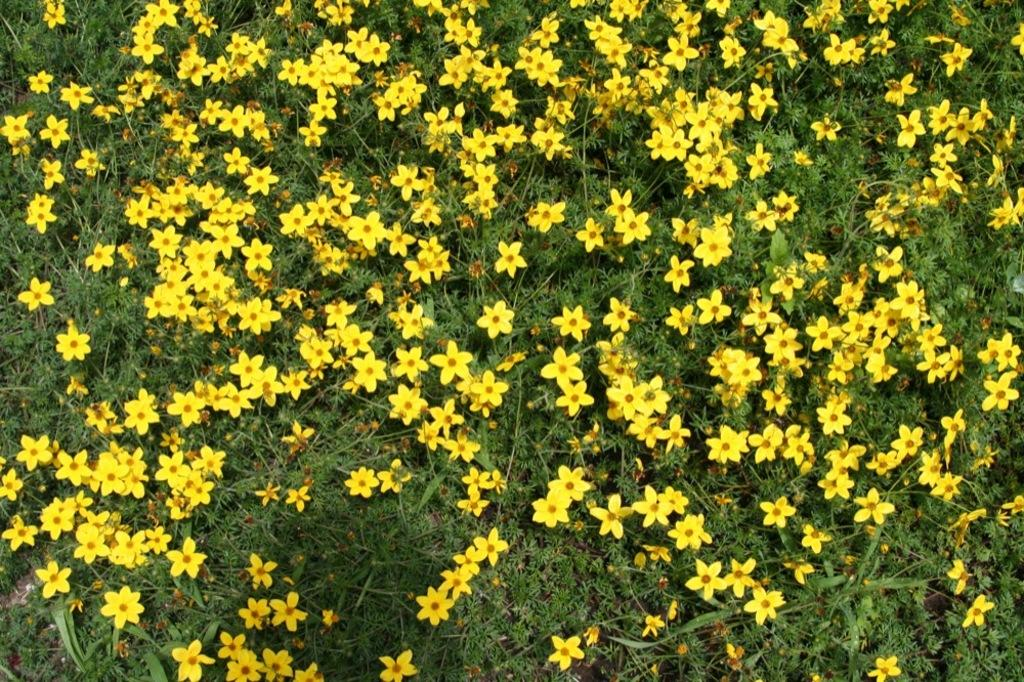What type of living organisms are present in the image? There are plants in the image. What specific feature can be observed on the plants? The plants have flowers. What color are the flowers on the plants? The flowers are yellow in color. What type of support does the carpenter provide to the plants in the image? There is no carpenter present in the image, and therefore no support is provided to the plants. What is the primary use of the plants in the image? The image does not provide information about the primary use of the plants. 